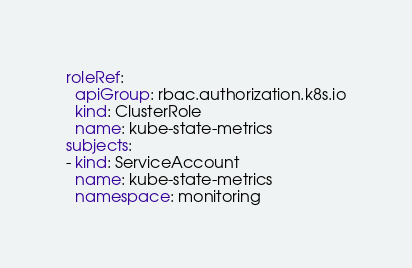<code> <loc_0><loc_0><loc_500><loc_500><_YAML_>roleRef:
  apiGroup: rbac.authorization.k8s.io
  kind: ClusterRole
  name: kube-state-metrics
subjects:
- kind: ServiceAccount
  name: kube-state-metrics
  namespace: monitoring</code> 